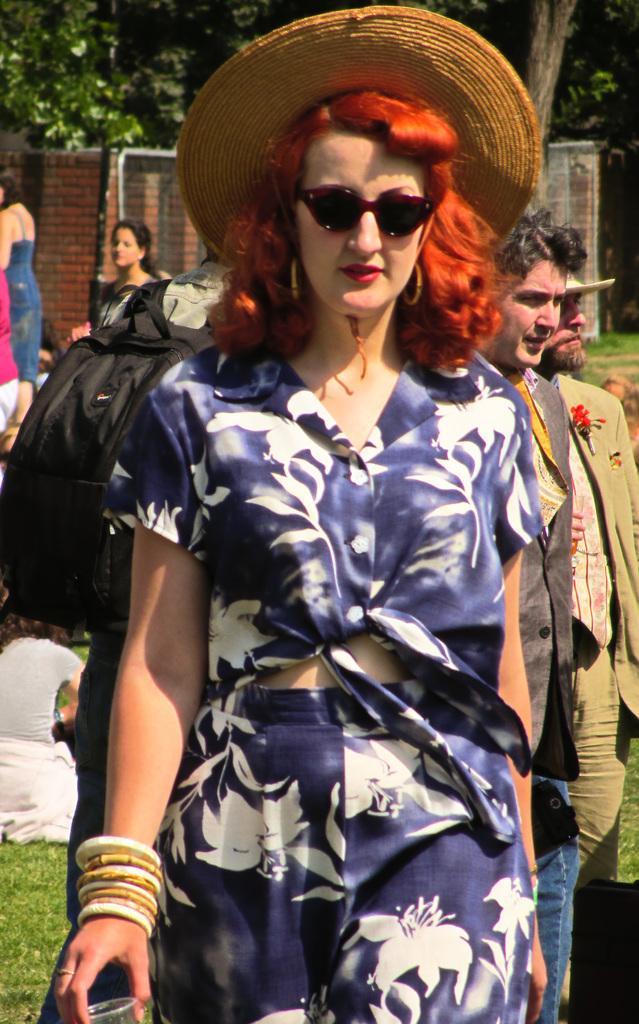How would you summarize this image in a sentence or two? In this image we can see a few people, one lady is holding a glass, another person is wearing backpack, there are trees, also we can see the wall. 